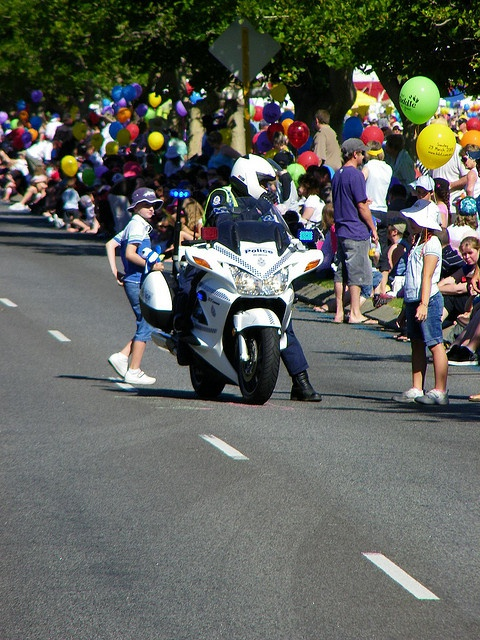Describe the objects in this image and their specific colors. I can see people in darkgreen, black, white, and navy tones, motorcycle in darkgreen, black, white, gray, and navy tones, people in darkgreen, black, navy, white, and gray tones, people in darkgreen, black, white, and gray tones, and people in darkgreen, black, purple, navy, and gray tones in this image. 